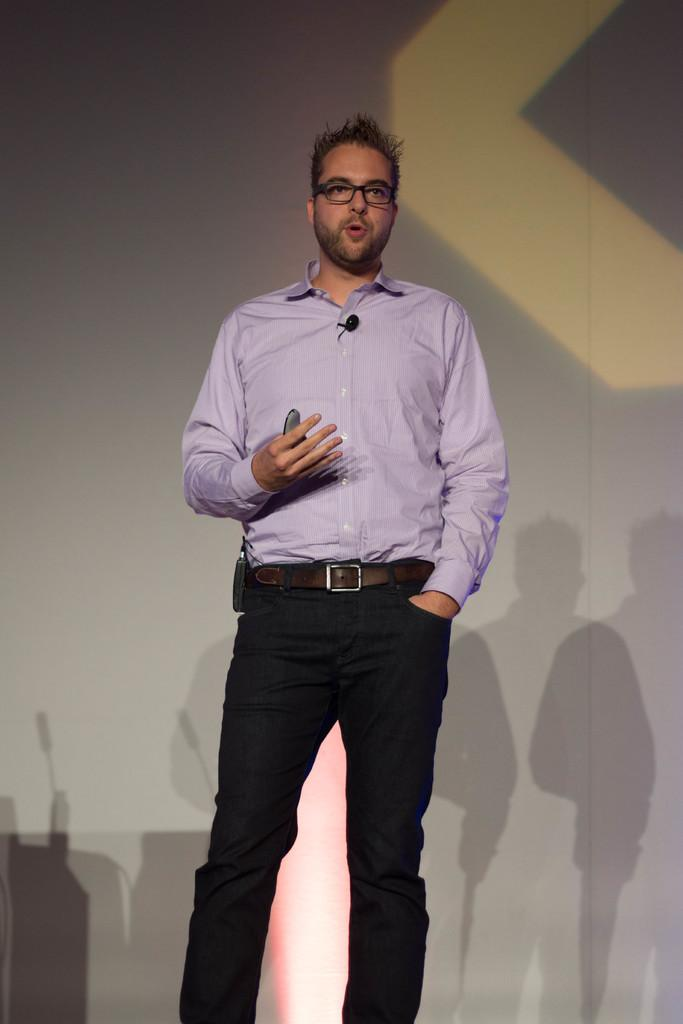What is the main subject of the image? There is a man in the image. What is the man doing in the image? The man is standing in the image. What is the man holding in his hand? The man is holding an object in his hand. Can you describe any additional features of the man in the image? There is a microphone attached to the man's shirt. What can be seen in the background of the image? There are shadows visible on the wall in the background of the image. What type of attraction can be seen in the image? There is no attraction present in the image; it features a man standing with a microphone attached to his shirt. Are there any bears visible in the image? There are no bears present in the image. 